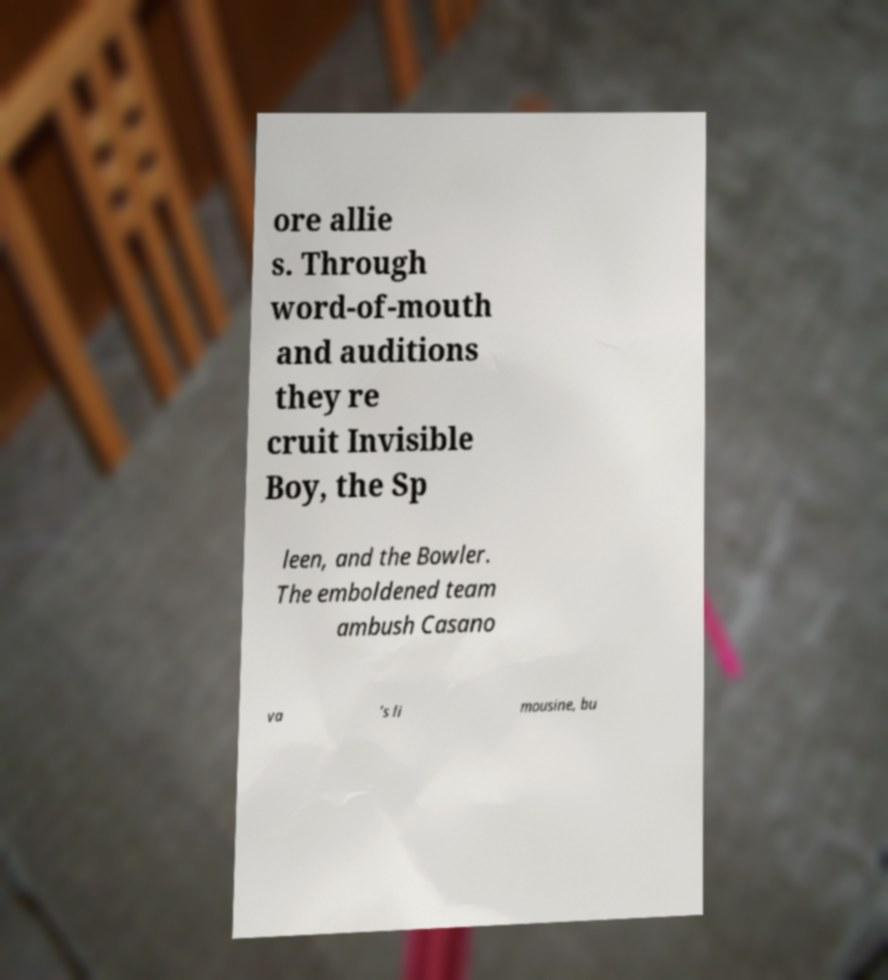Please read and relay the text visible in this image. What does it say? ore allie s. Through word-of-mouth and auditions they re cruit Invisible Boy, the Sp leen, and the Bowler. The emboldened team ambush Casano va ’s li mousine, bu 